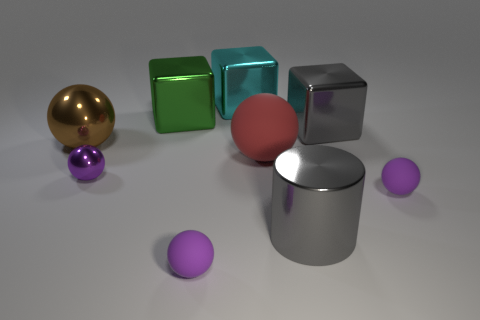There is a purple thing to the left of the green shiny object; is it the same shape as the brown metallic object?
Make the answer very short. Yes. There is a big sphere on the right side of the green thing; what is its material?
Provide a succinct answer. Rubber. What is the shape of the large object that is left of the large cylinder and right of the cyan metal block?
Provide a short and direct response. Sphere. What is the large gray cylinder made of?
Offer a terse response. Metal. What number of cubes are large red rubber objects or tiny yellow matte objects?
Ensure brevity in your answer.  0. Do the big brown ball and the gray cylinder have the same material?
Provide a short and direct response. Yes. What size is the gray metallic object that is the same shape as the large cyan object?
Offer a very short reply. Large. The sphere that is behind the tiny purple metal sphere and right of the big brown metallic object is made of what material?
Keep it short and to the point. Rubber. Are there an equal number of large brown shiny balls that are behind the large rubber thing and big matte spheres?
Give a very brief answer. Yes. What number of objects are metal blocks to the left of the large cyan metal object or tiny purple things?
Your answer should be compact. 4. 